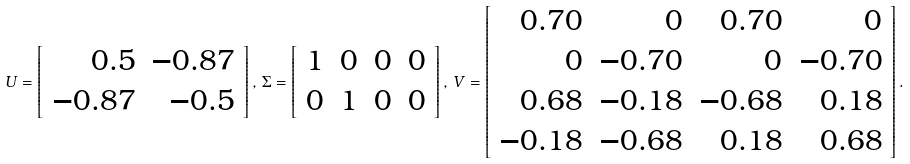Convert formula to latex. <formula><loc_0><loc_0><loc_500><loc_500>U = \left [ \begin{array} { r r } 0 . 5 & - 0 . 8 7 \\ - 0 . 8 7 & - 0 . 5 \end{array} \right ] , \, \Sigma = \left [ \begin{array} { r r r r } 1 & 0 & 0 & 0 \\ 0 & 1 & 0 & 0 \end{array} \right ] , \, V = \left [ \begin{array} { r r r r } 0 . 7 0 & 0 & 0 . 7 0 & 0 \\ 0 & - 0 . 7 0 & 0 & - 0 . 7 0 \\ 0 . 6 8 & - 0 . 1 8 & - 0 . 6 8 & 0 . 1 8 \\ - 0 . 1 8 & - 0 . 6 8 & 0 . 1 8 & 0 . 6 8 \end{array} \right ] .</formula> 